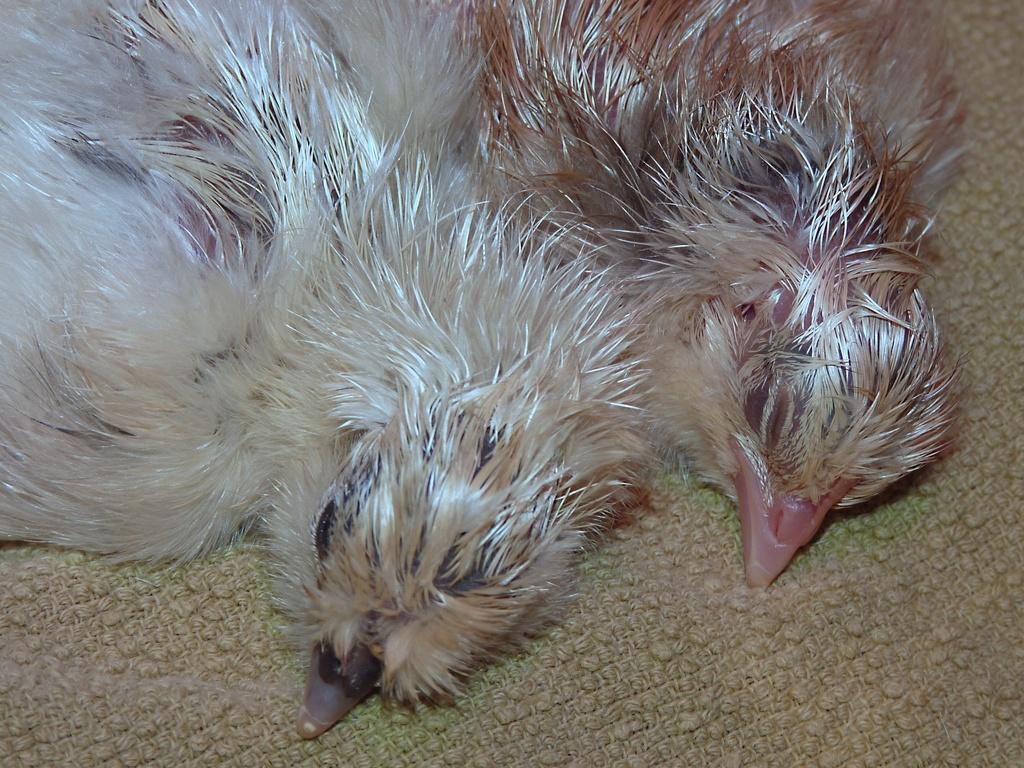In one or two sentences, can you explain what this image depicts? In this picture we can see two birds lying on a cloth. 